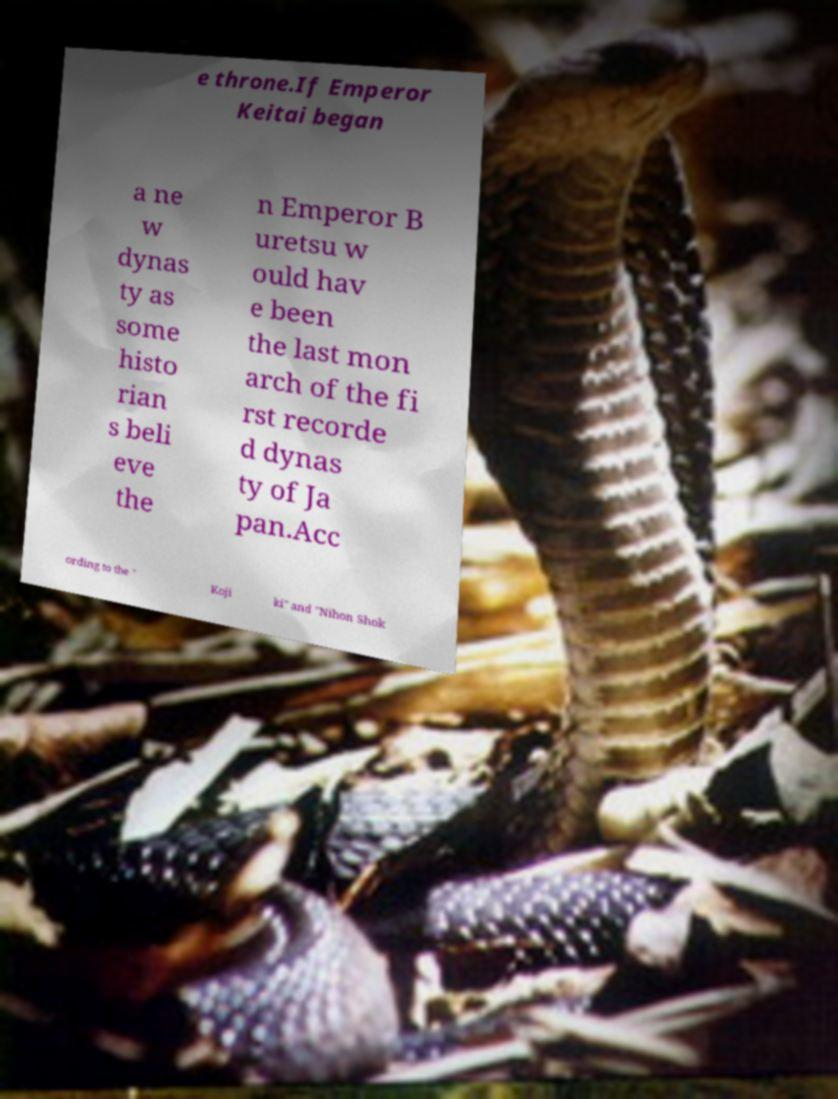I need the written content from this picture converted into text. Can you do that? e throne.If Emperor Keitai began a ne w dynas ty as some histo rian s beli eve the n Emperor B uretsu w ould hav e been the last mon arch of the fi rst recorde d dynas ty of Ja pan.Acc ording to the " Koji ki" and "Nihon Shok 